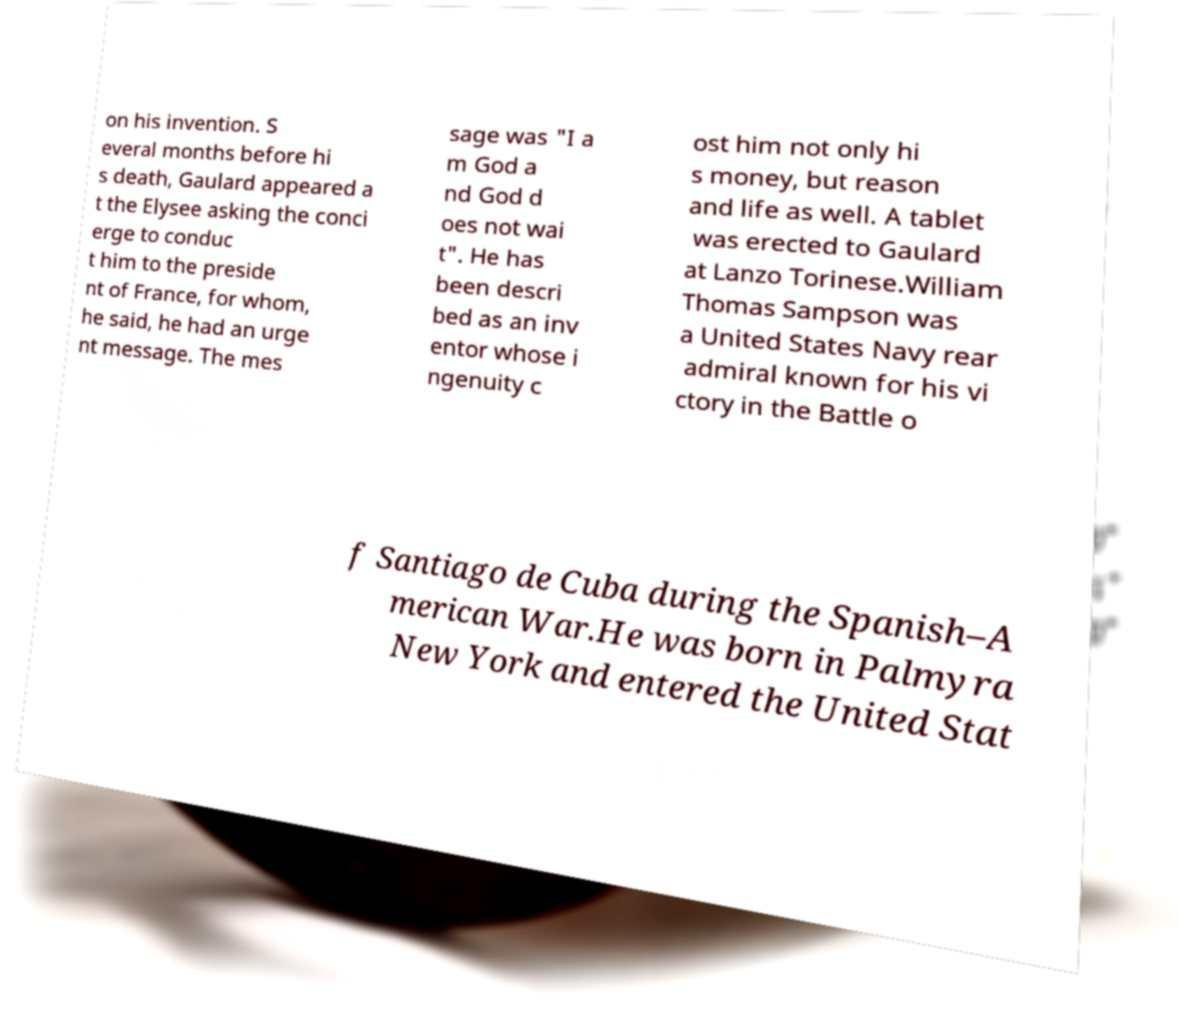Could you assist in decoding the text presented in this image and type it out clearly? on his invention. S everal months before hi s death, Gaulard appeared a t the Elysee asking the conci erge to conduc t him to the preside nt of France, for whom, he said, he had an urge nt message. The mes sage was "I a m God a nd God d oes not wai t". He has been descri bed as an inv entor whose i ngenuity c ost him not only hi s money, but reason and life as well. A tablet was erected to Gaulard at Lanzo Torinese.William Thomas Sampson was a United States Navy rear admiral known for his vi ctory in the Battle o f Santiago de Cuba during the Spanish–A merican War.He was born in Palmyra New York and entered the United Stat 